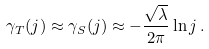<formula> <loc_0><loc_0><loc_500><loc_500>\gamma _ { T } ( j ) \approx \gamma _ { S } ( j ) \approx - \frac { \sqrt { \lambda } } { 2 \pi } \ln j \, .</formula> 